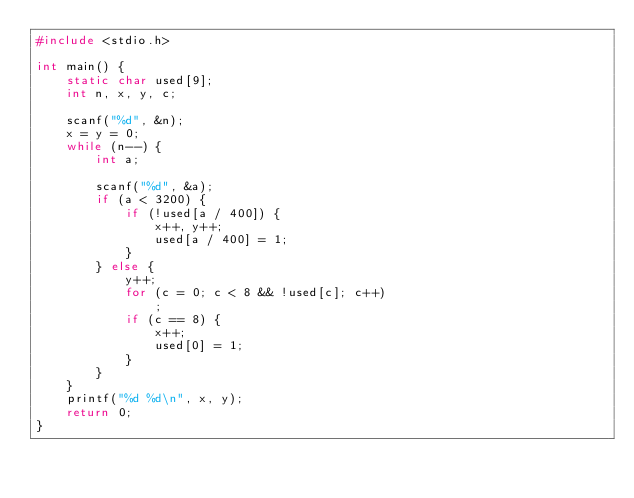Convert code to text. <code><loc_0><loc_0><loc_500><loc_500><_C_>#include <stdio.h>

int main() {
	static char used[9];
	int n, x, y, c;

	scanf("%d", &n);
	x = y = 0;
	while (n--) {
		int a;

		scanf("%d", &a);
		if (a < 3200) {
			if (!used[a / 400]) {
				x++, y++;
				used[a / 400] = 1;
			}
		} else {
			y++;
			for (c = 0; c < 8 && !used[c]; c++)
				;
			if (c == 8) {
				x++;
				used[0] = 1;
			}
		}
	}
	printf("%d %d\n", x, y);
	return 0;
}
</code> 